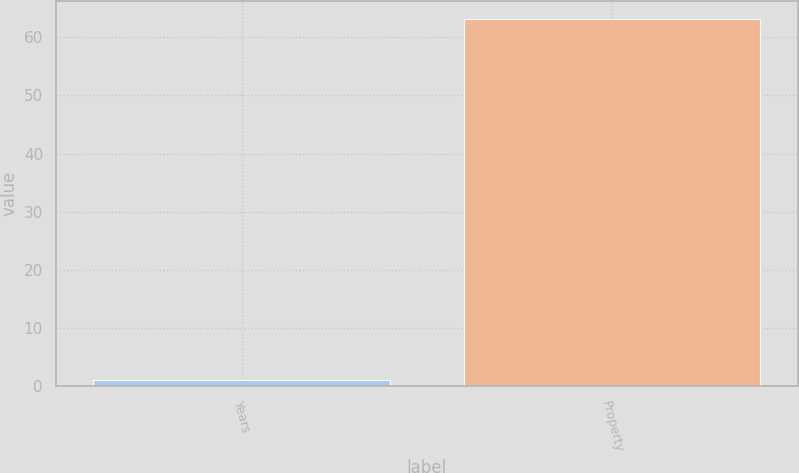<chart> <loc_0><loc_0><loc_500><loc_500><bar_chart><fcel>Years<fcel>Property<nl><fcel>1<fcel>63.1<nl></chart> 